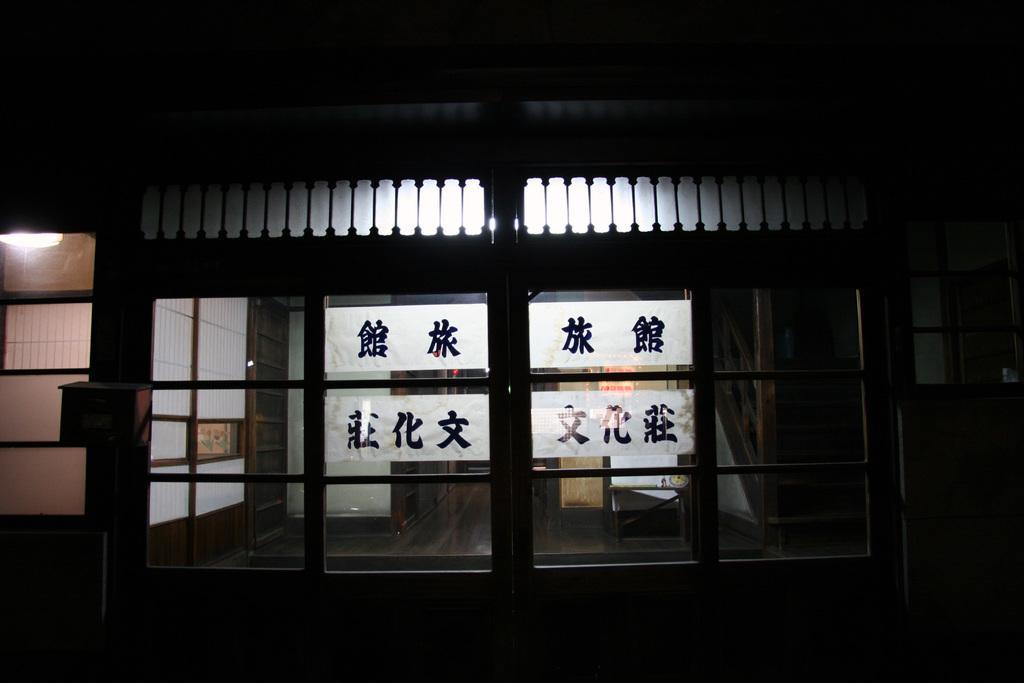In one or two sentences, can you explain what this image depicts? This picture is completely dark. At the top left corner we can see a light. Here we can see glass doors. 